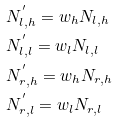Convert formula to latex. <formula><loc_0><loc_0><loc_500><loc_500>& N ^ { ^ { \prime } } _ { l , h } = w _ { h } N _ { l , h } \\ & N ^ { ^ { \prime } } _ { l , l } = w _ { l } N _ { l , l } \\ & N ^ { ^ { \prime } } _ { r , h } = w _ { h } N _ { r , h } \\ & N ^ { ^ { \prime } } _ { r , l } = w _ { l } N _ { r , l }</formula> 